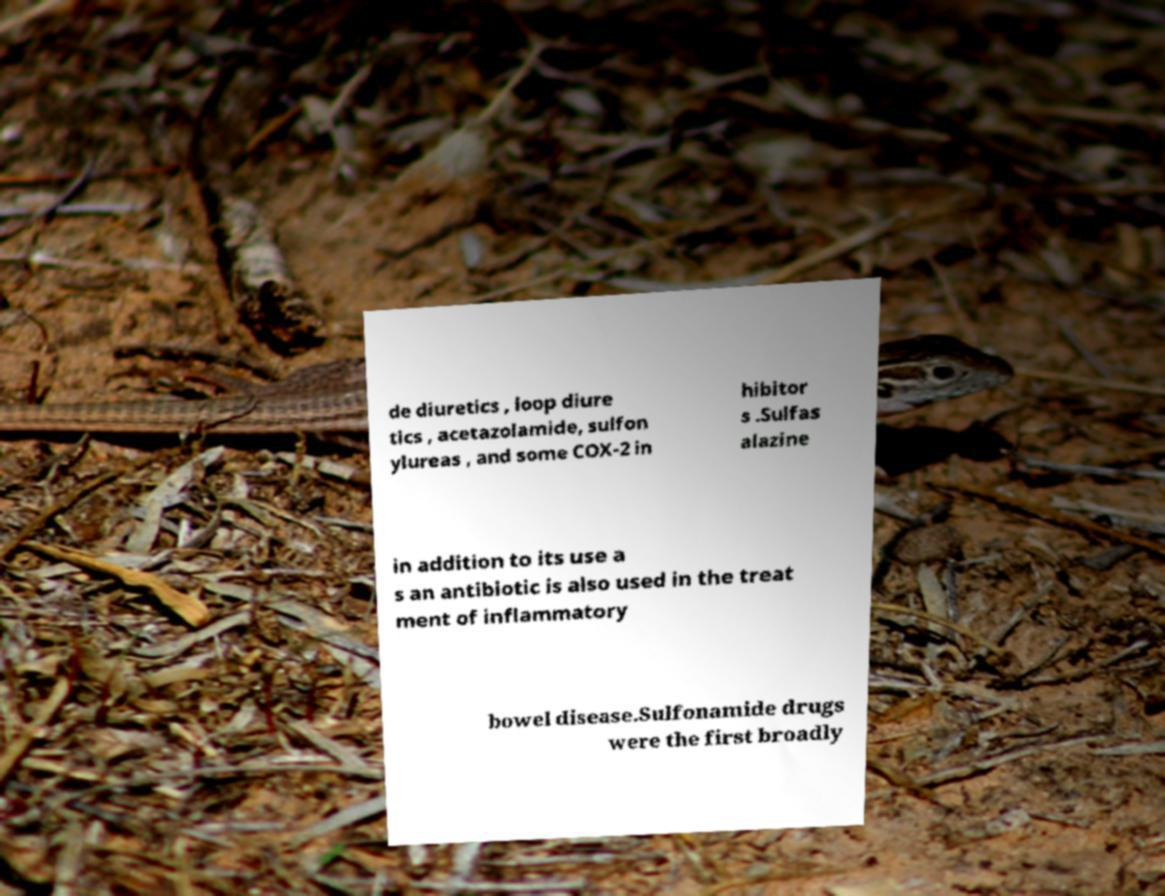There's text embedded in this image that I need extracted. Can you transcribe it verbatim? de diuretics , loop diure tics , acetazolamide, sulfon ylureas , and some COX-2 in hibitor s .Sulfas alazine in addition to its use a s an antibiotic is also used in the treat ment of inflammatory bowel disease.Sulfonamide drugs were the first broadly 